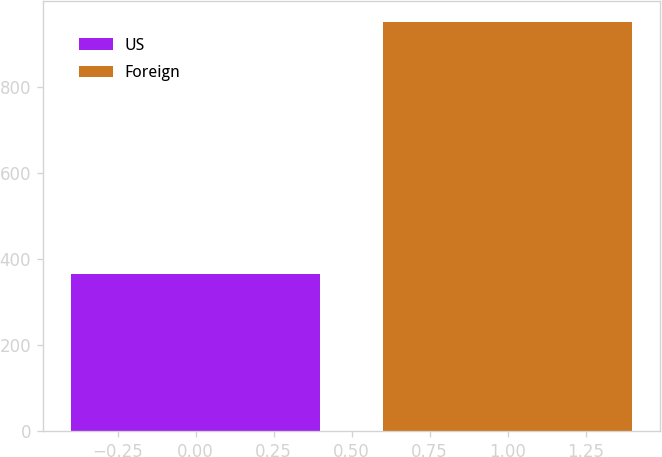<chart> <loc_0><loc_0><loc_500><loc_500><bar_chart><fcel>US<fcel>Foreign<nl><fcel>366<fcel>952<nl></chart> 